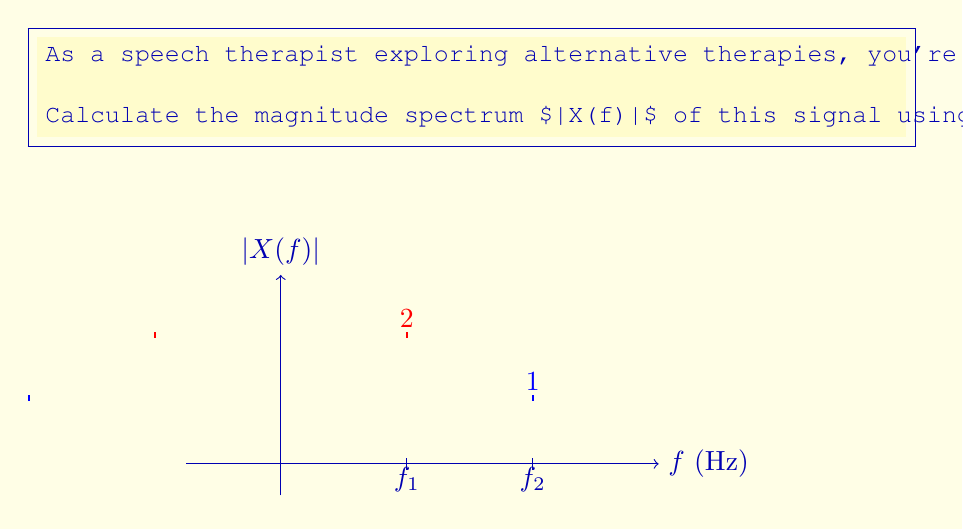Provide a solution to this math problem. Let's approach this step-by-step:

1) The Fourier transform of a cosine function is given by:

   $$\mathcal{F}\{\cos(2\pi f_0 t)\} = \frac{1}{2}[\delta(f-f_0) + \delta(f+f_0)]$$

   where $\delta(f)$ is the Dirac delta function.

2) For our signal $x(t) = 2\cos(2\pi f_1 t) + \cos(2\pi f_2 t)$, we can apply linearity and scaling properties of the Fourier transform:

   $$X(f) = 2 \cdot \frac{1}{2}[\delta(f-f_1) + \delta(f+f_1)] + \frac{1}{2}[\delta(f-f_2) + \delta(f+f_2)]$$

3) Simplifying:

   $$X(f) = [\delta(f-f_1) + \delta(f+f_1)] + \frac{1}{2}[\delta(f-f_2) + \delta(f+f_2)]$$

4) The magnitude spectrum $|X(f)|$ is the absolute value of $X(f)$. Since the Dirac delta function is real and positive, we don't need to change anything:

   $$|X(f)| = [\delta(f-f_1) + \delta(f+f_1)] + \frac{1}{2}[\delta(f-f_2) + \delta(f+f_2)]$$

5) This spectrum has four non-zero components:
   - At $f = \pm f_1 = \pm 200$ Hz with magnitude 1
   - At $f = \pm f_2 = \pm 400$ Hz with magnitude 0.5

The positive frequencies correspond to the original cosine terms, while the negative frequencies arise from the complex conjugate symmetry of the Fourier transform for real signals.
Answer: $\pm 200$ Hz (magnitude 1), $\pm 400$ Hz (magnitude 0.5) 